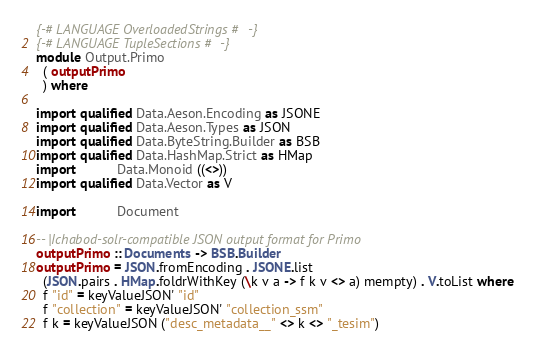Convert code to text. <code><loc_0><loc_0><loc_500><loc_500><_Haskell_>{-# LANGUAGE OverloadedStrings #-}
{-# LANGUAGE TupleSections #-}
module Output.Primo
  ( outputPrimo
  ) where

import qualified Data.Aeson.Encoding as JSONE
import qualified Data.Aeson.Types as JSON
import qualified Data.ByteString.Builder as BSB
import qualified Data.HashMap.Strict as HMap
import           Data.Monoid ((<>))
import qualified Data.Vector as V

import           Document

-- |Ichabod-solr-compatible JSON output format for Primo
outputPrimo :: Documents -> BSB.Builder
outputPrimo = JSON.fromEncoding . JSONE.list
  (JSON.pairs . HMap.foldrWithKey (\k v a -> f k v <> a) mempty) . V.toList where
  f "id" = keyValueJSON' "id"
  f "collection" = keyValueJSON' "collection_ssm"
  f k = keyValueJSON ("desc_metadata__" <> k <> "_tesim")
</code> 